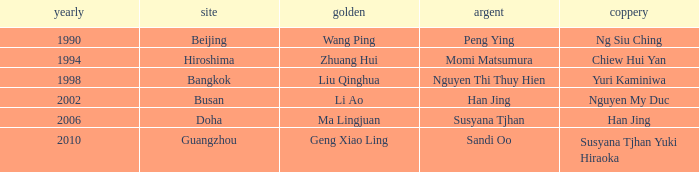Which gold items are linked to the year 1994? Zhuang Hui. 